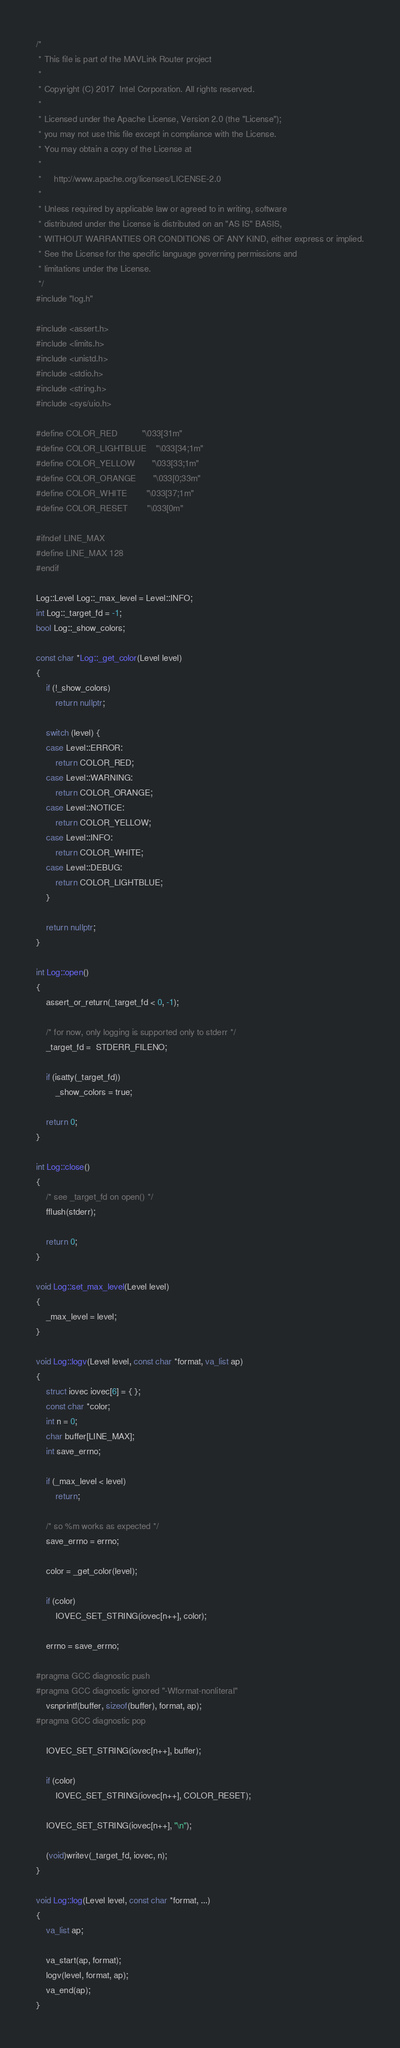Convert code to text. <code><loc_0><loc_0><loc_500><loc_500><_C++_>/*
 * This file is part of the MAVLink Router project
 *
 * Copyright (C) 2017  Intel Corporation. All rights reserved.
 *
 * Licensed under the Apache License, Version 2.0 (the "License");
 * you may not use this file except in compliance with the License.
 * You may obtain a copy of the License at
 *
 *     http://www.apache.org/licenses/LICENSE-2.0
 *
 * Unless required by applicable law or agreed to in writing, software
 * distributed under the License is distributed on an "AS IS" BASIS,
 * WITHOUT WARRANTIES OR CONDITIONS OF ANY KIND, either express or implied.
 * See the License for the specific language governing permissions and
 * limitations under the License.
 */
#include "log.h"

#include <assert.h>
#include <limits.h>
#include <unistd.h>
#include <stdio.h>
#include <string.h>
#include <sys/uio.h>

#define COLOR_RED          "\033[31m"
#define COLOR_LIGHTBLUE    "\033[34;1m"
#define COLOR_YELLOW       "\033[33;1m"
#define COLOR_ORANGE       "\033[0;33m"
#define COLOR_WHITE        "\033[37;1m"
#define COLOR_RESET        "\033[0m"

#ifndef LINE_MAX
#define LINE_MAX 128
#endif

Log::Level Log::_max_level = Level::INFO;
int Log::_target_fd = -1;
bool Log::_show_colors;

const char *Log::_get_color(Level level)
{
    if (!_show_colors)
        return nullptr;

    switch (level) {
    case Level::ERROR:
        return COLOR_RED;
    case Level::WARNING:
        return COLOR_ORANGE;
    case Level::NOTICE:
        return COLOR_YELLOW;
    case Level::INFO:
        return COLOR_WHITE;
    case Level::DEBUG:
        return COLOR_LIGHTBLUE;
    }

    return nullptr;
}

int Log::open()
{
    assert_or_return(_target_fd < 0, -1);

    /* for now, only logging is supported only to stderr */
    _target_fd =  STDERR_FILENO;

    if (isatty(_target_fd))
        _show_colors = true;

    return 0;
}

int Log::close()
{
    /* see _target_fd on open() */
    fflush(stderr);

    return 0;
}

void Log::set_max_level(Level level)
{
    _max_level = level;
}

void Log::logv(Level level, const char *format, va_list ap)
{
    struct iovec iovec[6] = { };
    const char *color;
    int n = 0;
    char buffer[LINE_MAX];
    int save_errno;

    if (_max_level < level)
        return;

    /* so %m works as expected */
    save_errno = errno;

    color = _get_color(level);

    if (color)
        IOVEC_SET_STRING(iovec[n++], color);

    errno = save_errno;

#pragma GCC diagnostic push
#pragma GCC diagnostic ignored "-Wformat-nonliteral"
    vsnprintf(buffer, sizeof(buffer), format, ap);
#pragma GCC diagnostic pop

    IOVEC_SET_STRING(iovec[n++], buffer);

    if (color)
        IOVEC_SET_STRING(iovec[n++], COLOR_RESET);

    IOVEC_SET_STRING(iovec[n++], "\n");

    (void)writev(_target_fd, iovec, n);
}

void Log::log(Level level, const char *format, ...)
{
    va_list ap;

    va_start(ap, format);
    logv(level, format, ap);
    va_end(ap);
}
</code> 